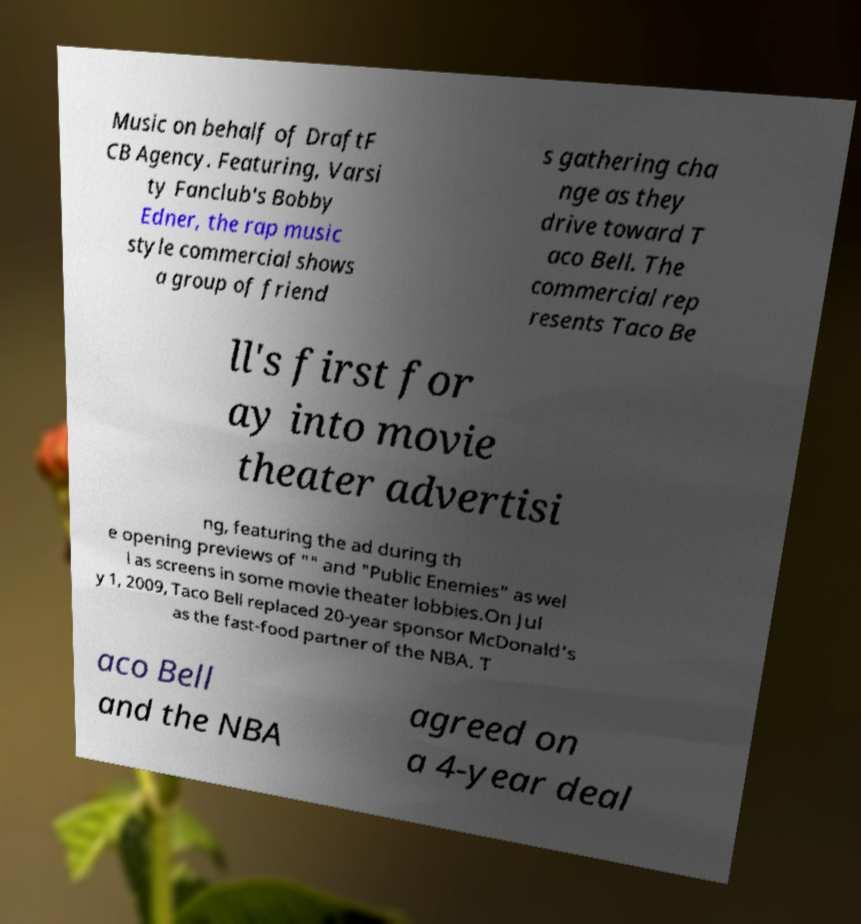What messages or text are displayed in this image? I need them in a readable, typed format. Music on behalf of DraftF CB Agency. Featuring, Varsi ty Fanclub's Bobby Edner, the rap music style commercial shows a group of friend s gathering cha nge as they drive toward T aco Bell. The commercial rep resents Taco Be ll's first for ay into movie theater advertisi ng, featuring the ad during th e opening previews of "" and "Public Enemies" as wel l as screens in some movie theater lobbies.On Jul y 1, 2009, Taco Bell replaced 20-year sponsor McDonald's as the fast-food partner of the NBA. T aco Bell and the NBA agreed on a 4-year deal 